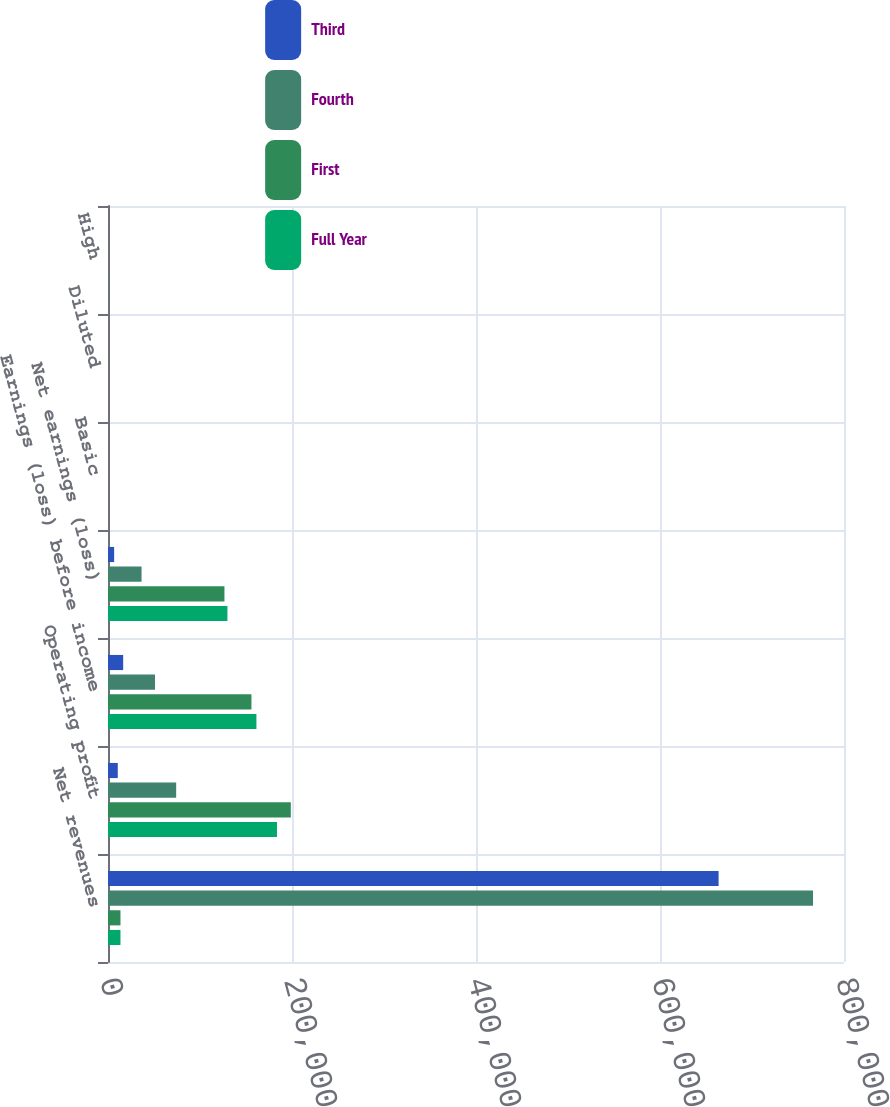Convert chart. <chart><loc_0><loc_0><loc_500><loc_500><stacked_bar_chart><ecel><fcel>Net revenues<fcel>Operating profit<fcel>Earnings (loss) before income<fcel>Net earnings (loss)<fcel>Basic<fcel>Diluted<fcel>High<nl><fcel>Third<fcel>663694<fcel>10627<fcel>16493<fcel>6671<fcel>0.05<fcel>0.05<fcel>44.14<nl><fcel>Fourth<fcel>766342<fcel>74088<fcel>51076<fcel>36480<fcel>0.28<fcel>0.28<fcel>48.97<nl><fcel>First<fcel>13560<fcel>198706<fcel>155913<fcel>126574<fcel>0.97<fcel>0.96<fcel>49.75<nl><fcel>Full Year<fcel>13560<fcel>183672<fcel>161326<fcel>129815<fcel>0.99<fcel>0.98<fcel>54.55<nl></chart> 